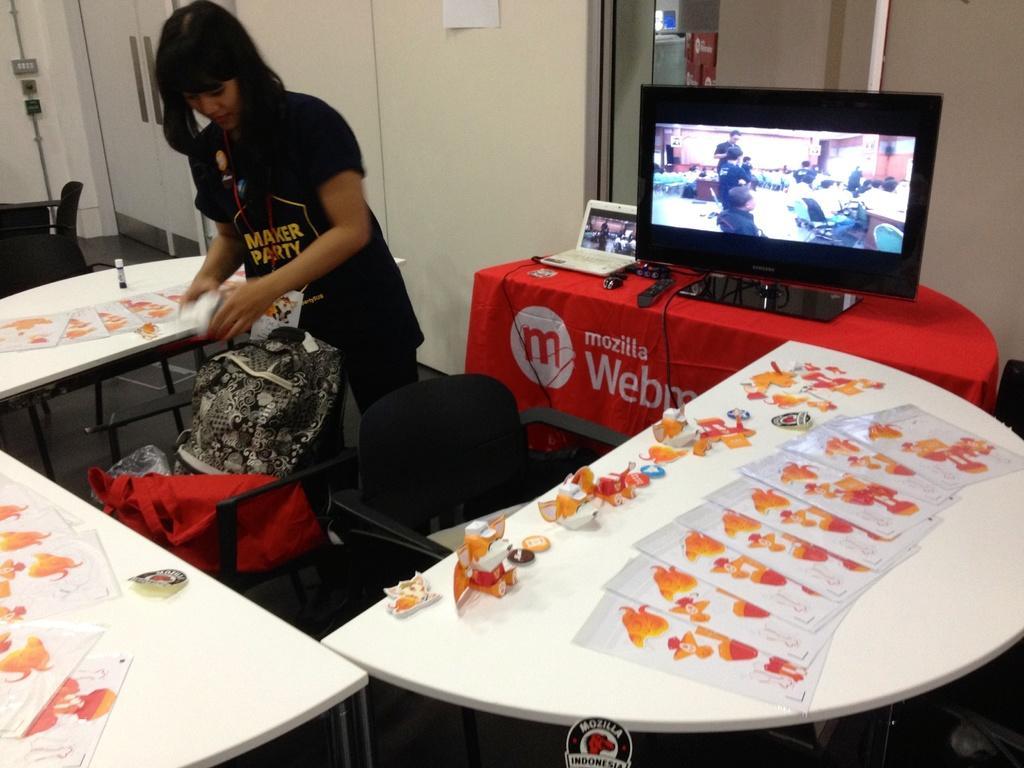Can you describe this image briefly? In this image the woman is standing. There is television,laptop and remote on the table. The cloth is covered to the table. There is a bag on the chair. At the background we can see a switch board on the wall. There are papers and toys on the table. 